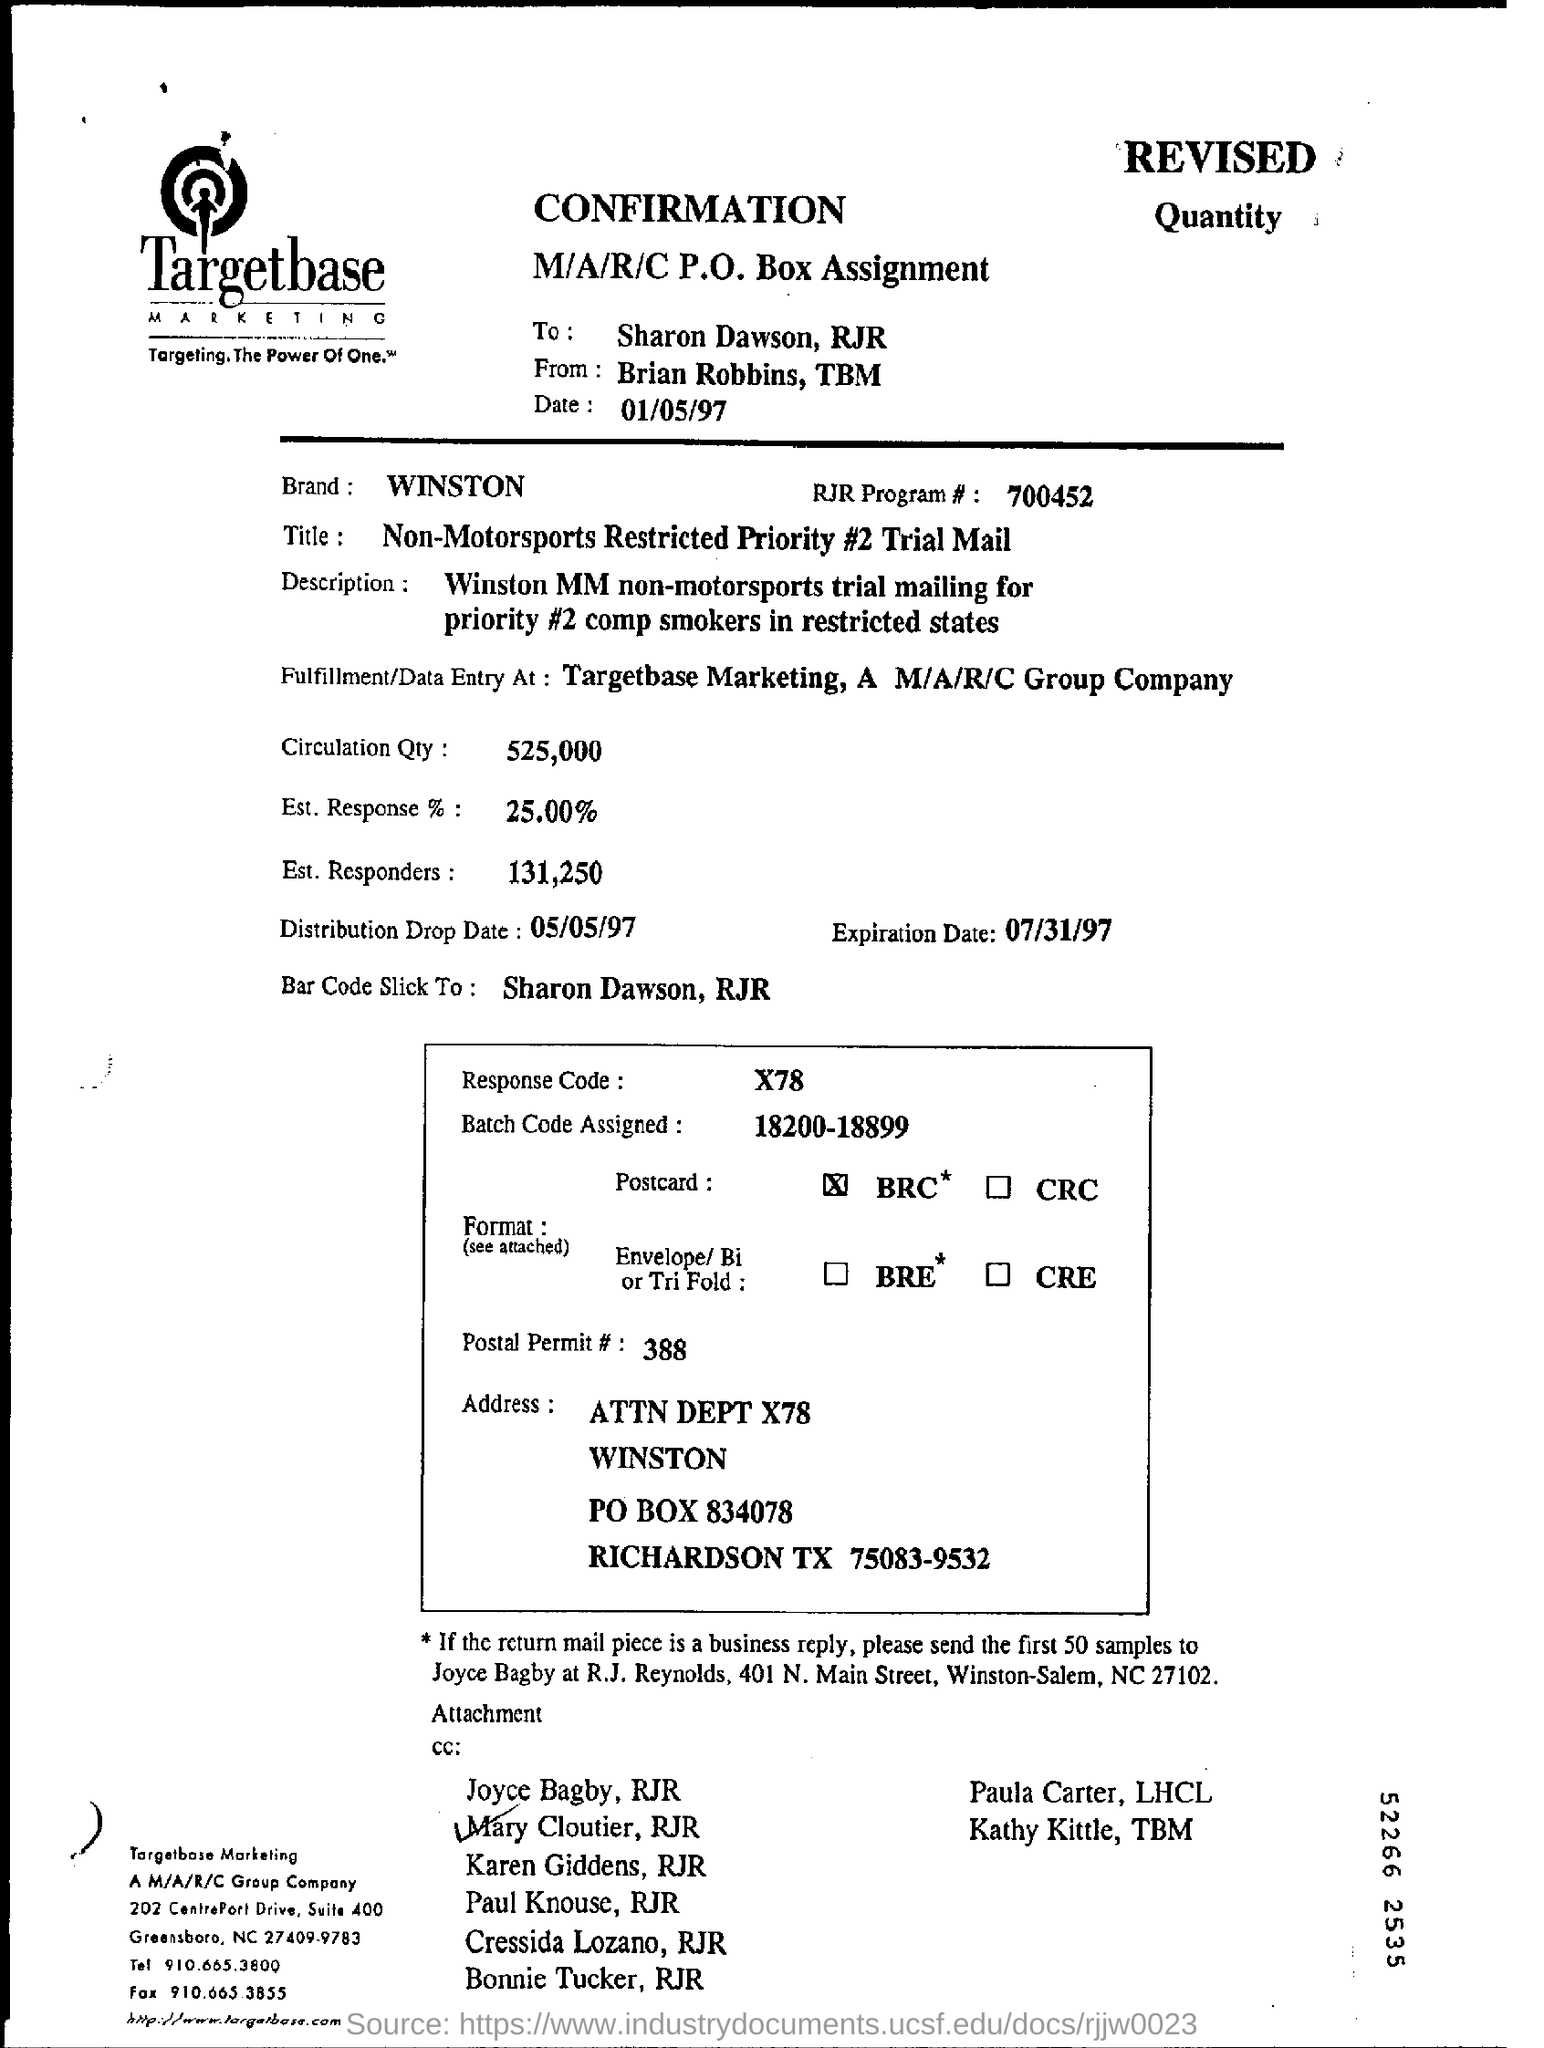Who is it addressed to?
Give a very brief answer. Sharon Dawson, RJR. What is the Date?
Your answer should be compact. 01/05/97. What is the Brand?
Keep it short and to the point. Winston. What is the RJR Program #?
Offer a very short reply. 700452. What is the Circulation Qty?
Ensure brevity in your answer.  525,000. What is the Est Response %?
Provide a succinct answer. 25.00. What is the Est. Responders?
Your answer should be very brief. 131,250. What is the Batch Code assigned?
Provide a succinct answer. 18200-18899. What is the Response code?
Ensure brevity in your answer.  X78. 